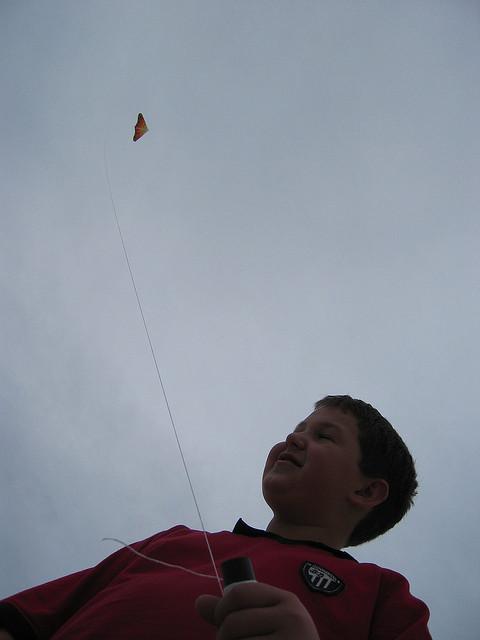Which hand holds the line?
Be succinct. Left. What number is on the man's shirt?
Answer briefly. 0. Is the kite flyer wearing glasses?
Quick response, please. No. How many kites are in the sky?
Quick response, please. 1. Does the person in the red shirt have his mouth open?
Write a very short answer. No. Is this little kid holding a brown bear?
Give a very brief answer. No. Is the kid smiling?
Give a very brief answer. Yes. Is it a cloudy day?
Be succinct. Yes. What is the kid looking up into the sky at?
Concise answer only. Kite. Is he doing a trick?
Be succinct. No. 